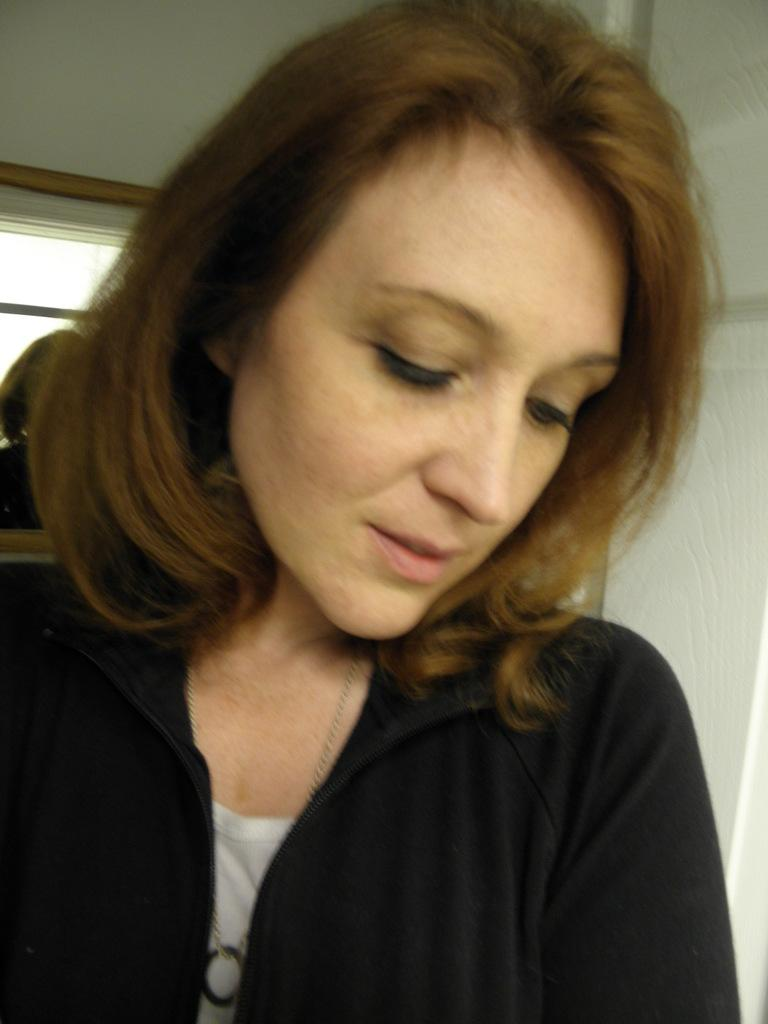Who is the main subject in the image? There is a woman in the image. What is the woman wearing? The woman is wearing a black jacket. What can be seen in the background of the image? There is a wall, a person, and a window in the background of the image. How many girls are playing in harmony in the image? There are no girls or any indication of harmony present in the image. 